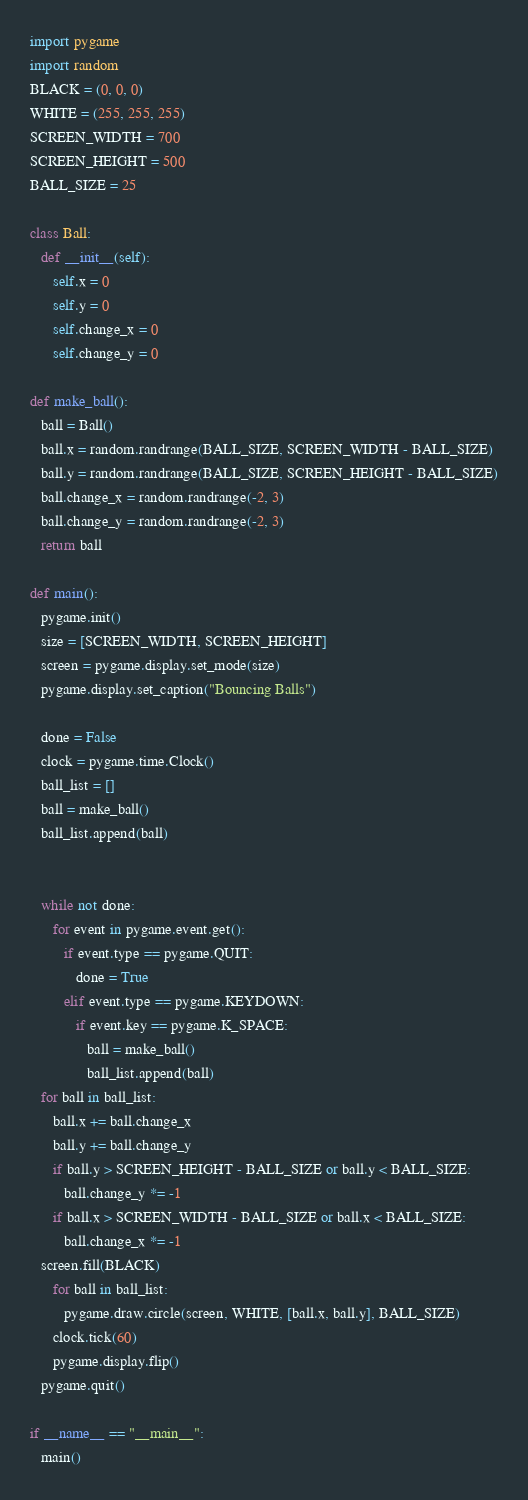<code> <loc_0><loc_0><loc_500><loc_500><_Python_>import pygame
import random
BLACK = (0, 0, 0)
WHITE = (255, 255, 255)
SCREEN_WIDTH = 700
SCREEN_HEIGHT = 500
BALL_SIZE = 25

class Ball:
   def __init__(self):
      self.x = 0
      self.y = 0
      self.change_x = 0
      self.change_y = 0

def make_ball():
   ball = Ball()
   ball.x = random.randrange(BALL_SIZE, SCREEN_WIDTH - BALL_SIZE)
   ball.y = random.randrange(BALL_SIZE, SCREEN_HEIGHT - BALL_SIZE)
   ball.change_x = random.randrange(-2, 3)
   ball.change_y = random.randrange(-2, 3)
   return ball

def main():
   pygame.init()
   size = [SCREEN_WIDTH, SCREEN_HEIGHT]
   screen = pygame.display.set_mode(size)
   pygame.display.set_caption("Bouncing Balls")

   done = False
   clock = pygame.time.Clock()
   ball_list = []
   ball = make_ball()
   ball_list.append(ball)
   

   while not done:
      for event in pygame.event.get():
         if event.type == pygame.QUIT:
            done = True
         elif event.type == pygame.KEYDOWN:
            if event.key == pygame.K_SPACE:
               ball = make_ball()
               ball_list.append(ball)
   for ball in ball_list:
      ball.x += ball.change_x
      ball.y += ball.change_y
      if ball.y > SCREEN_HEIGHT - BALL_SIZE or ball.y < BALL_SIZE:
         ball.change_y *= -1
      if ball.x > SCREEN_WIDTH - BALL_SIZE or ball.x < BALL_SIZE:
         ball.change_x *= -1
   screen.fill(BLACK)
      for ball in ball_list:
         pygame.draw.circle(screen, WHITE, [ball.x, ball.y], BALL_SIZE)
      clock.tick(60)
      pygame.display.flip()
   pygame.quit()

if __name__ == "__main__":
   main()
</code> 